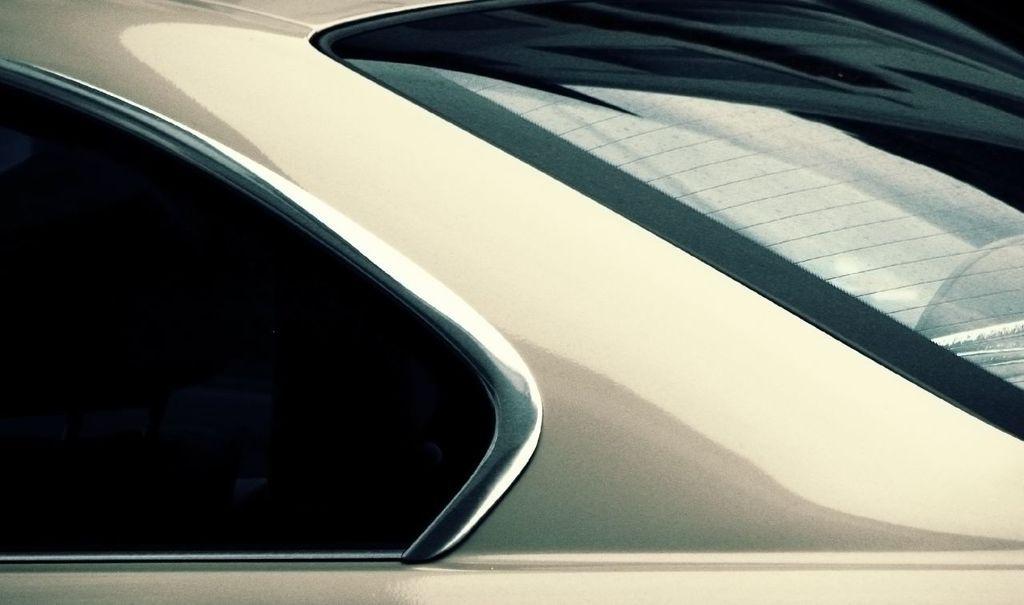In one or two sentences, can you explain what this image depicts? In this picture we can see a vehicle, we can see a glass of the vehicle on the right side. 